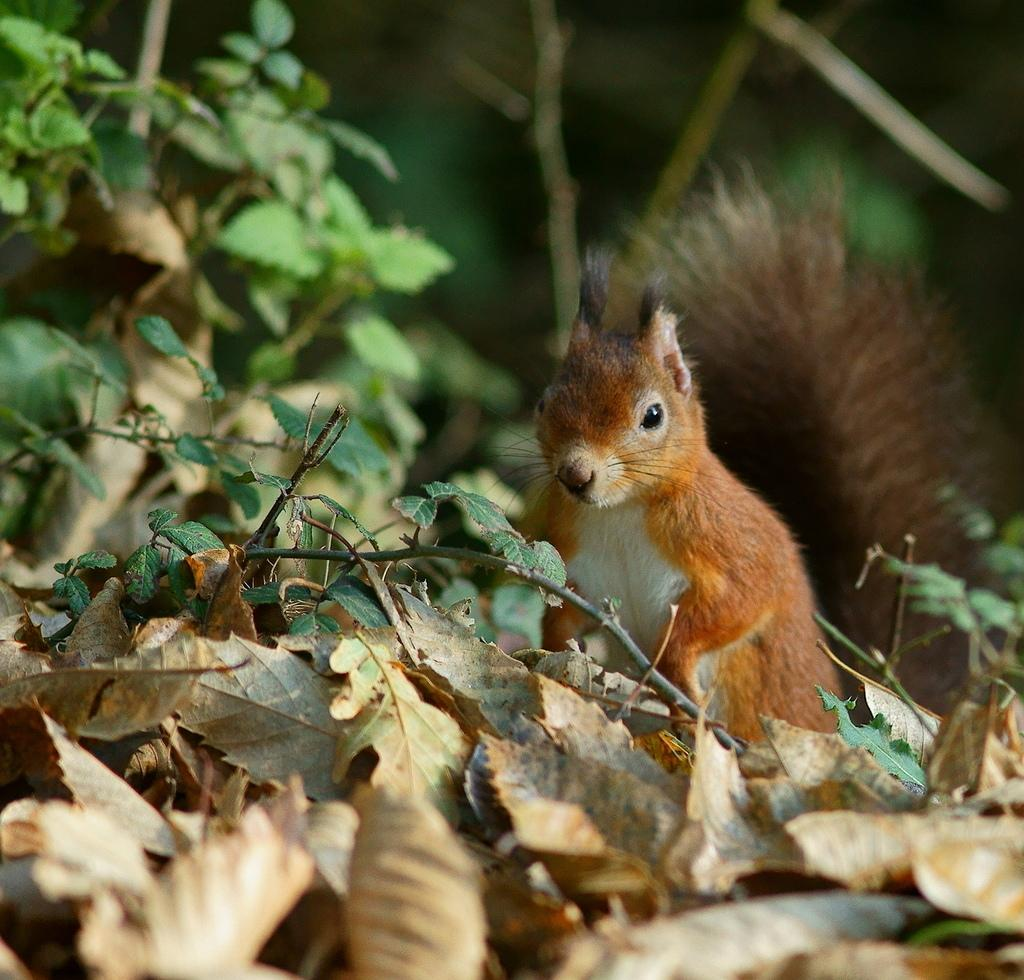What type of animal can be seen in the image? There is a squirrel in the image. What can be found on the ground in the image? There are dried leaves on the ground in the image. What else can be seen in the image besides the squirrel and dried leaves? There are stems with leaves in the image. Can you describe the background of the image? The background of the image is blurry. What type of band is playing music in the background of the image? There is no band present in the image; it only features a squirrel, dried leaves, stems with leaves, and a blurry background. 